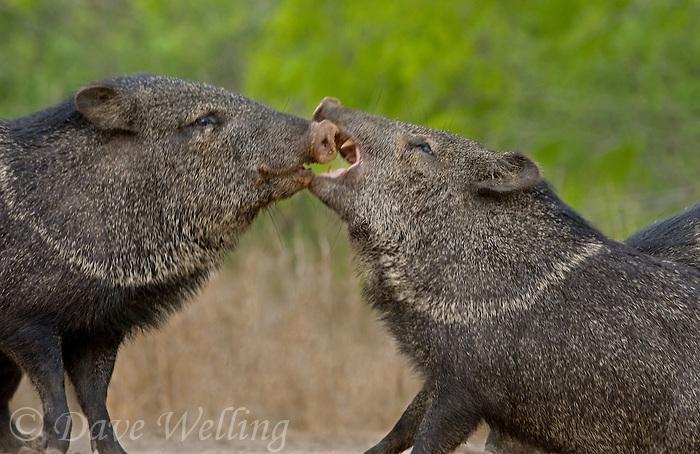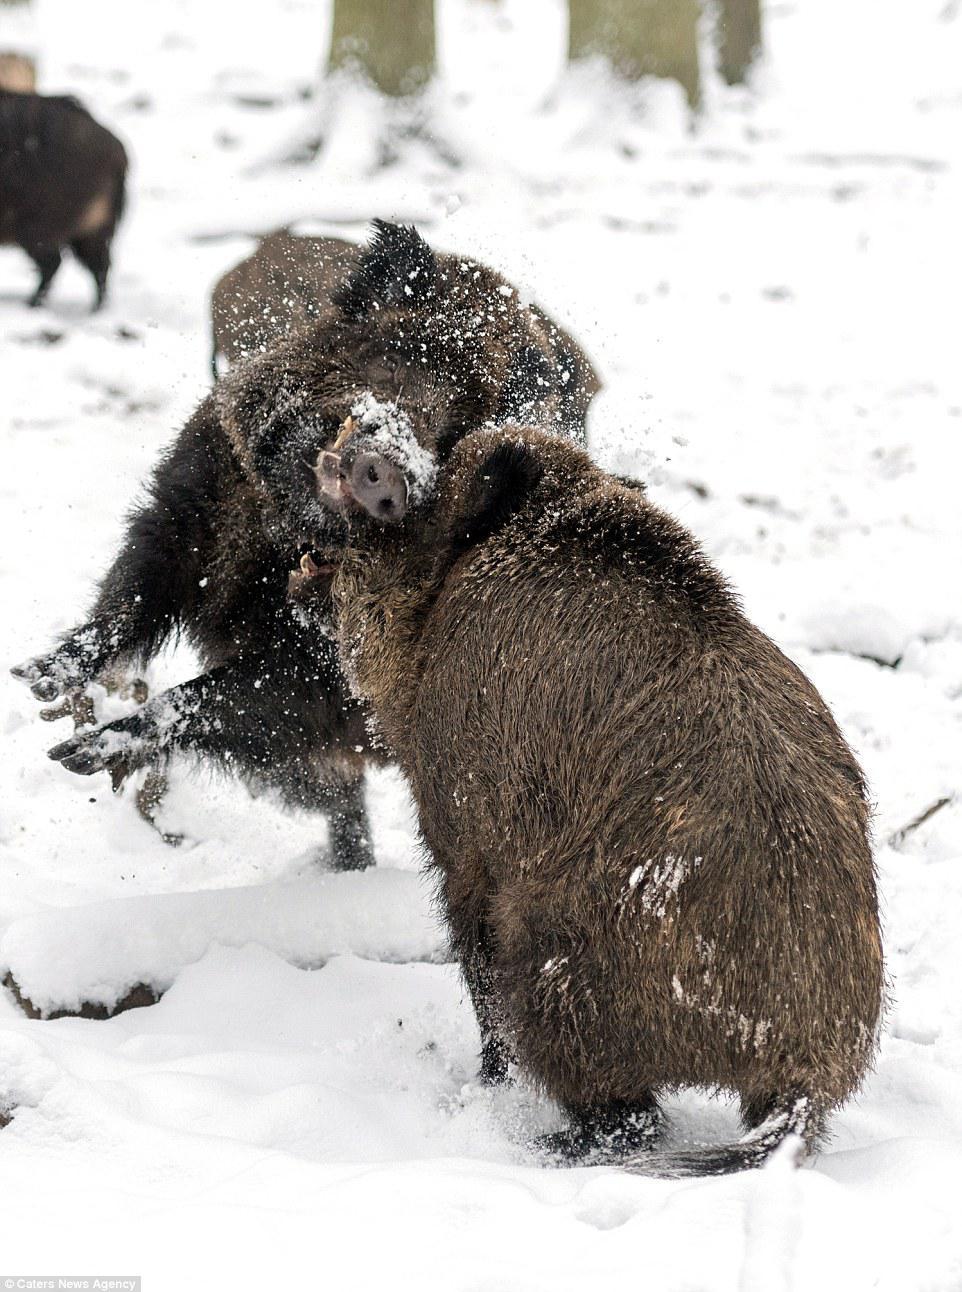The first image is the image on the left, the second image is the image on the right. Assess this claim about the two images: "A single wild pig is in the snow in each of the images.". Correct or not? Answer yes or no. No. 